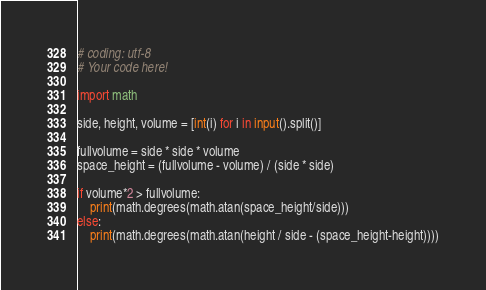<code> <loc_0><loc_0><loc_500><loc_500><_Python_># coding: utf-8
# Your code here!

import math

side, height, volume = [int(i) for i in input().split()]

fullvolume = side * side * volume
space_height = (fullvolume - volume) / (side * side)

if volume*2 > fullvolume:
    print(math.degrees(math.atan(space_height/side)))
else:
    print(math.degrees(math.atan(height / side - (space_height-height))))</code> 